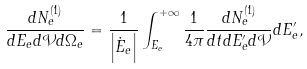<formula> <loc_0><loc_0><loc_500><loc_500>\frac { d N _ { e } ^ { ( 1 ) } } { d E _ { e } d \mathcal { V } d \Omega _ { e } } = \frac { 1 } { \left | \dot { E } _ { e } \right | } \int _ { E _ { e } } ^ { + \infty } \frac { 1 } { 4 \pi } \frac { d N _ { e } ^ { ( 1 ) } } { d t d E ^ { \prime } _ { e } d \mathcal { V } } d E ^ { \prime } _ { e } ,</formula> 